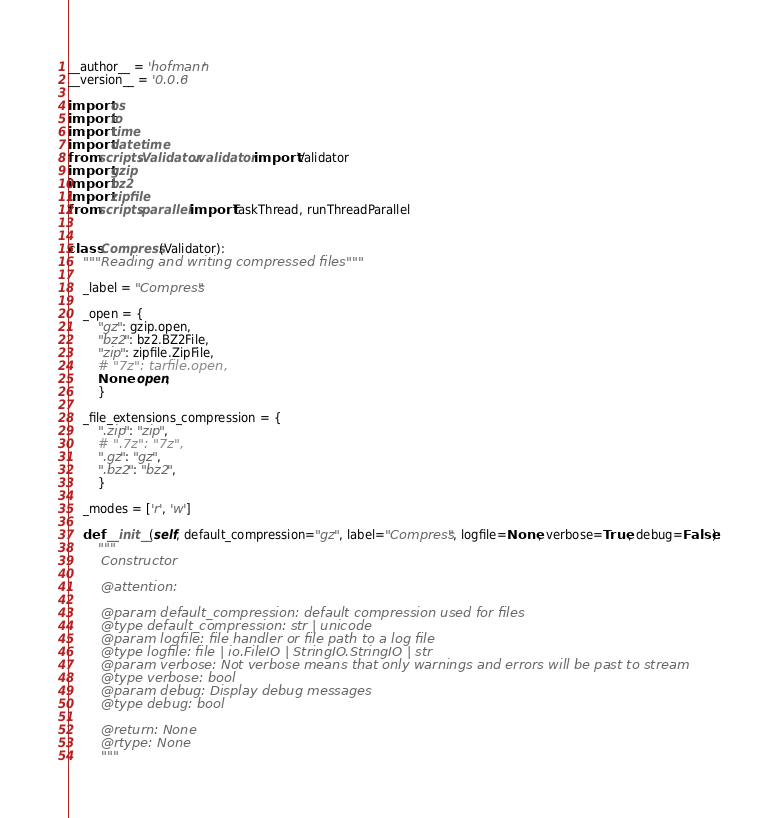Convert code to text. <code><loc_0><loc_0><loc_500><loc_500><_Python_>__author__ = 'hofmann'
__version__ = '0.0.6'

import os
import io
import time
import datetime
from scripts.Validator.validator import Validator
import gzip
import bz2
import zipfile
from scripts.parallel import TaskThread, runThreadParallel


class Compress(Validator):
    """Reading and writing compressed files"""

    _label = "Compress"

    _open = {
        "gz": gzip.open,
        "bz2": bz2.BZ2File,
        "zip": zipfile.ZipFile,
        # "7z": tarfile.open,
        None: open,
        }

    _file_extensions_compression = {
        ".zip": "zip",
        # ".7z": "7z",
        ".gz": "gz",
        ".bz2": "bz2",
        }

    _modes = ['r', 'w']

    def __init__(self, default_compression="gz", label="Compress", logfile=None, verbose=True, debug=False):
        """
        Constructor

        @attention:

        @param default_compression: default compression used for files
        @type default_compression: str | unicode
        @param logfile: file handler or file path to a log file
        @type logfile: file | io.FileIO | StringIO.StringIO | str
        @param verbose: Not verbose means that only warnings and errors will be past to stream
        @type verbose: bool
        @param debug: Display debug messages
        @type debug: bool

        @return: None
        @rtype: None
        """</code> 